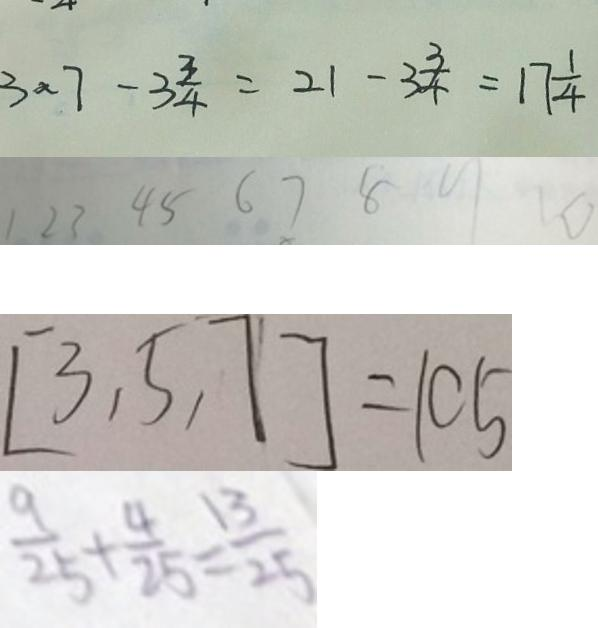<formula> <loc_0><loc_0><loc_500><loc_500>3 \times 7 - 3 \frac { 3 } { 4 } = 2 1 - 3 \frac { 3 } { 4 } = 1 7 \frac { 1 } { 4 } 
 1 2 3 4 5 6 7 8 9 1 0 
 [ 3 , 5 , 7 ] = 1 0 5 
 \frac { 9 } { 1 4 } + \frac { 4 } { 2 5 } = \frac { 1 3 } { 2 5 }</formula> 